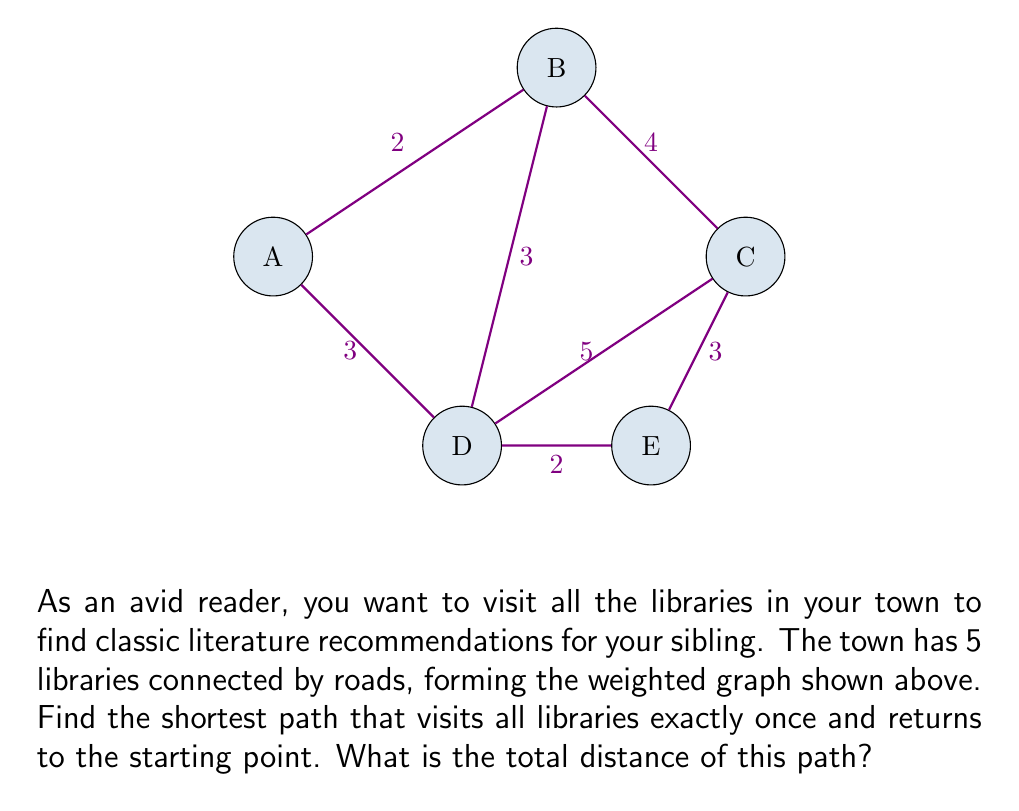Give your solution to this math problem. To solve this problem, we need to find the Hamiltonian cycle with the minimum total weight in the given graph. This is known as the Traveling Salesman Problem (TSP).

For a small graph like this, we can use a brute-force approach to find the optimal solution:

1) List all possible Hamiltonian cycles:
   A-B-C-D-E-A
   A-B-C-E-D-A
   A-B-D-C-E-A
   A-B-D-E-C-A
   A-B-E-C-D-A
   A-B-E-D-C-A
   (and their reverses, which will have the same total distance)

2) Calculate the total distance for each cycle:

   A-B-C-D-E-A: $2 + 4 + 5 + 2 + 3 = 16$
   A-B-C-E-D-A: $2 + 4 + 3 + 2 + 3 = 14$
   A-B-D-C-E-A: $2 + 3 + 5 + 3 + 3 = 16$
   A-B-D-E-C-A: $2 + 3 + 2 + 3 + 4 = 14$
   A-B-E-C-D-A: $2 + 7 + 3 + 5 + 3 = 20$
   A-B-E-D-C-A: $2 + 7 + 2 + 5 + 4 = 20$

3) Identify the minimum total distance:
   The minimum total distance is 14, which occurs for two cycles:
   A-B-C-E-D-A and A-B-D-E-C-A

Therefore, the shortest path to visit all libraries exactly once and return to the starting point has a total distance of 14 units.
Answer: 14 units 